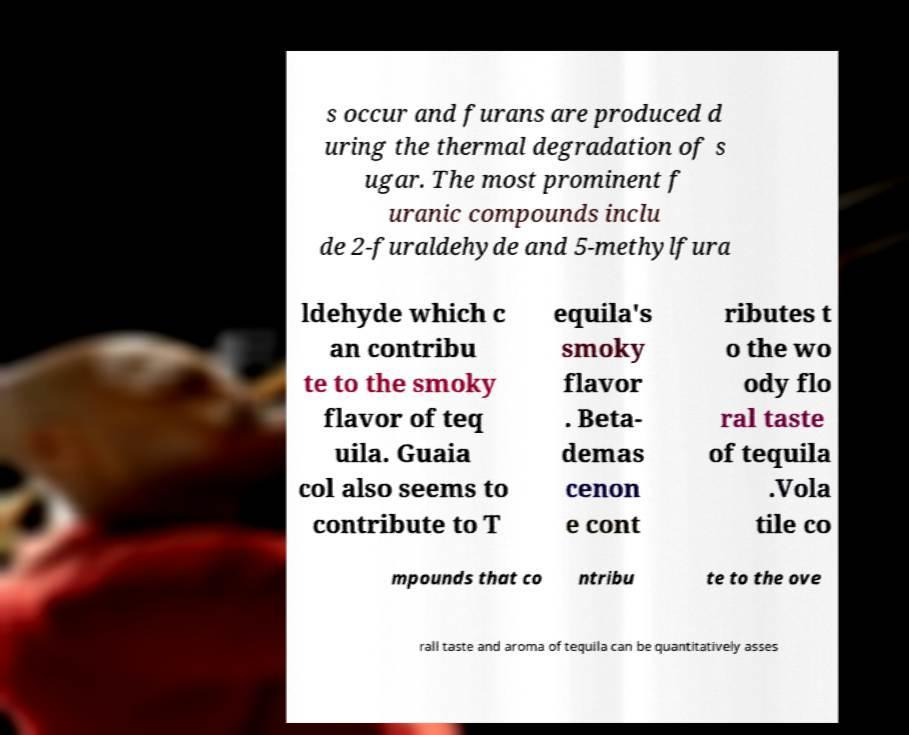Can you accurately transcribe the text from the provided image for me? s occur and furans are produced d uring the thermal degradation of s ugar. The most prominent f uranic compounds inclu de 2-furaldehyde and 5-methylfura ldehyde which c an contribu te to the smoky flavor of teq uila. Guaia col also seems to contribute to T equila's smoky flavor . Beta- demas cenon e cont ributes t o the wo ody flo ral taste of tequila .Vola tile co mpounds that co ntribu te to the ove rall taste and aroma of tequila can be quantitatively asses 